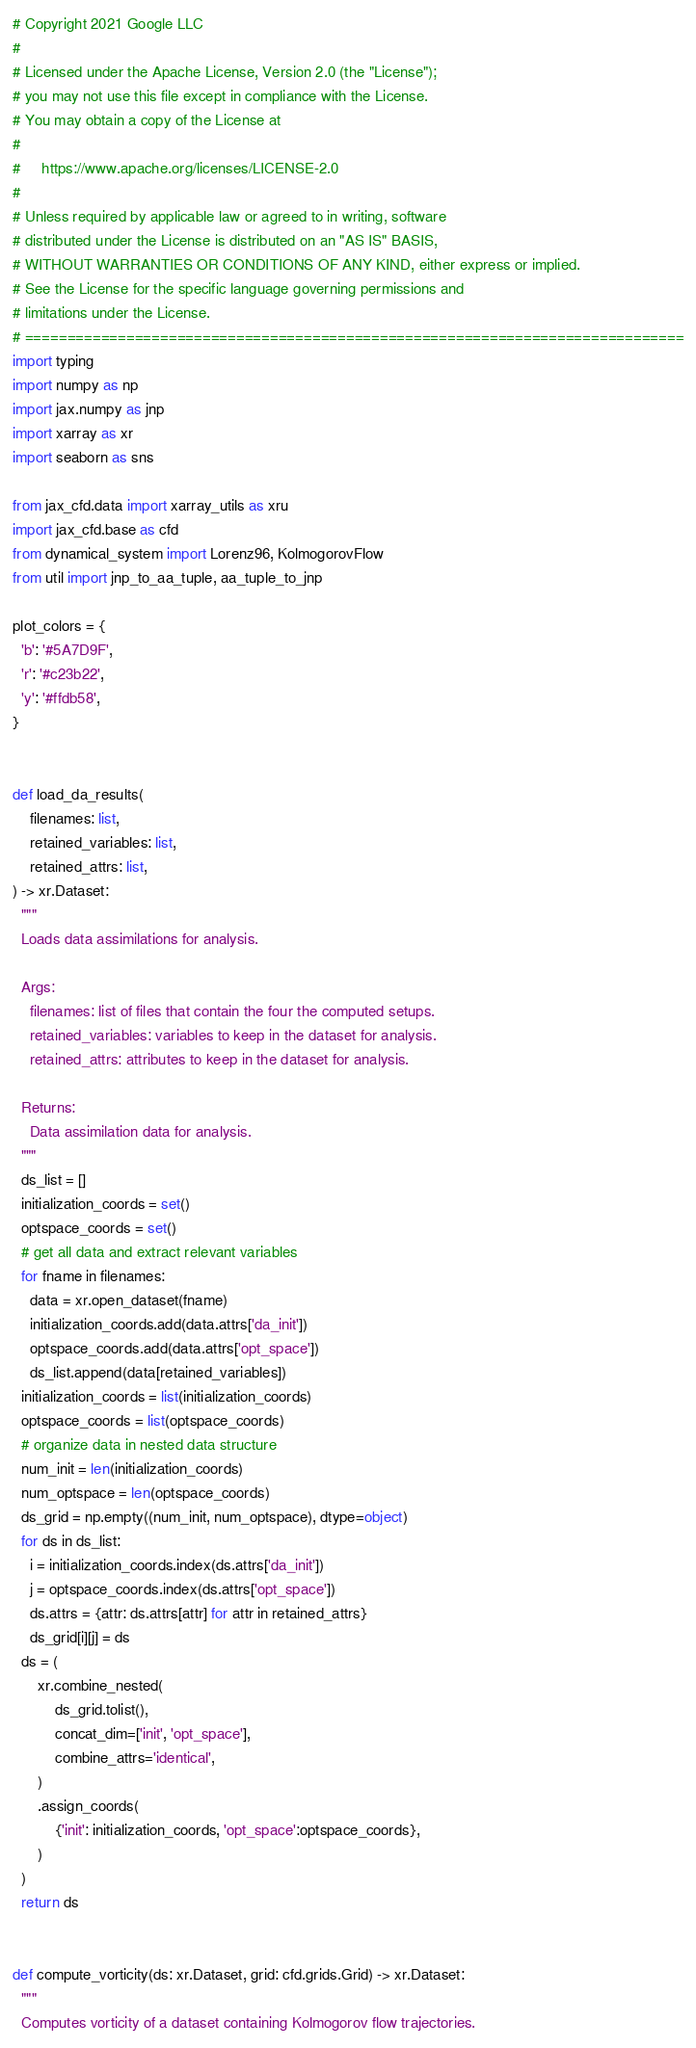<code> <loc_0><loc_0><loc_500><loc_500><_Python_># Copyright 2021 Google LLC
#
# Licensed under the Apache License, Version 2.0 (the "License");
# you may not use this file except in compliance with the License.
# You may obtain a copy of the License at
#
#     https://www.apache.org/licenses/LICENSE-2.0
#
# Unless required by applicable law or agreed to in writing, software
# distributed under the License is distributed on an "AS IS" BASIS,
# WITHOUT WARRANTIES OR CONDITIONS OF ANY KIND, either express or implied.
# See the License for the specific language governing permissions and
# limitations under the License.
# ==============================================================================
import typing
import numpy as np
import jax.numpy as jnp
import xarray as xr
import seaborn as sns

from jax_cfd.data import xarray_utils as xru
import jax_cfd.base as cfd
from dynamical_system import Lorenz96, KolmogorovFlow
from util import jnp_to_aa_tuple, aa_tuple_to_jnp

plot_colors = {
  'b': '#5A7D9F',
  'r': '#c23b22',
  'y': '#ffdb58',
}


def load_da_results(
    filenames: list, 
    retained_variables: list, 
    retained_attrs: list,
) -> xr.Dataset:
  """
  Loads data assimilations for analysis.
  
  Args:
    filenames: list of files that contain the four the computed setups.
    retained_variables: variables to keep in the dataset for analysis.
    retained_attrs: attributes to keep in the dataset for analysis.
    
  Returns:
    Data assimilation data for analysis.
  """
  ds_list = []
  initialization_coords = set()
  optspace_coords = set()
  # get all data and extract relevant variables
  for fname in filenames:
    data = xr.open_dataset(fname)
    initialization_coords.add(data.attrs['da_init'])
    optspace_coords.add(data.attrs['opt_space'])
    ds_list.append(data[retained_variables])
  initialization_coords = list(initialization_coords)
  optspace_coords = list(optspace_coords)
  # organize data in nested data structure
  num_init = len(initialization_coords)
  num_optspace = len(optspace_coords)
  ds_grid = np.empty((num_init, num_optspace), dtype=object)
  for ds in ds_list:
    i = initialization_coords.index(ds.attrs['da_init'])
    j = optspace_coords.index(ds.attrs['opt_space'])
    ds.attrs = {attr: ds.attrs[attr] for attr in retained_attrs}
    ds_grid[i][j] = ds
  ds = (
      xr.combine_nested(
          ds_grid.tolist(), 
          concat_dim=['init', 'opt_space'], 
          combine_attrs='identical',
      )
      .assign_coords(
          {'init': initialization_coords, 'opt_space':optspace_coords},
      )
  )
  return ds


def compute_vorticity(ds: xr.Dataset, grid: cfd.grids.Grid) -> xr.Dataset:
  """
  Computes vorticity of a dataset containing Kolmogorov flow trajectories.</code> 